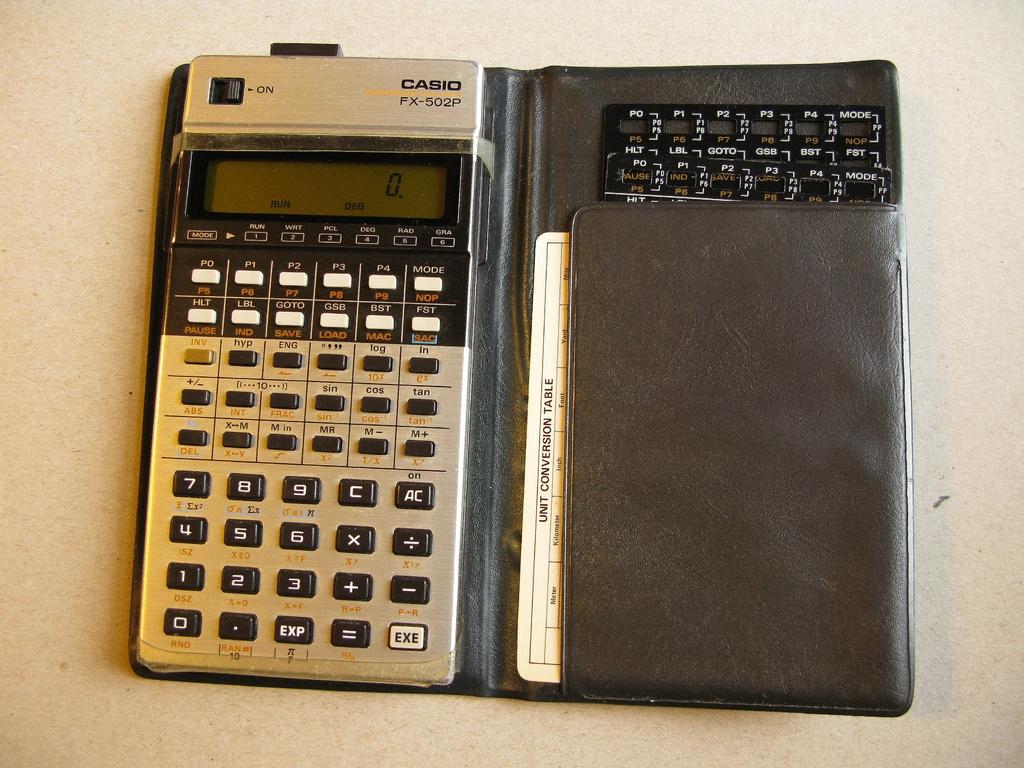What company made this calculator?
Make the answer very short. Casio. 